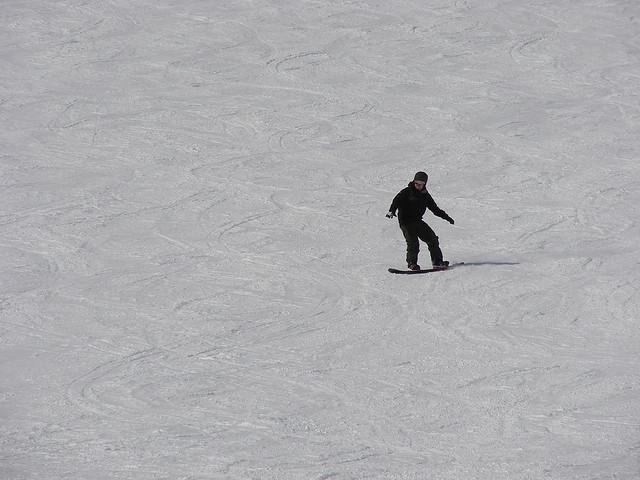Was this photo taken during the summer season?
Quick response, please. No. Where is the person?
Keep it brief. Outside. Is this person snowboarding?
Concise answer only. Yes. How do you know other snowboarders have been down the mountain already?
Quick response, please. Tracks. Is the snow deep?
Give a very brief answer. Yes. 